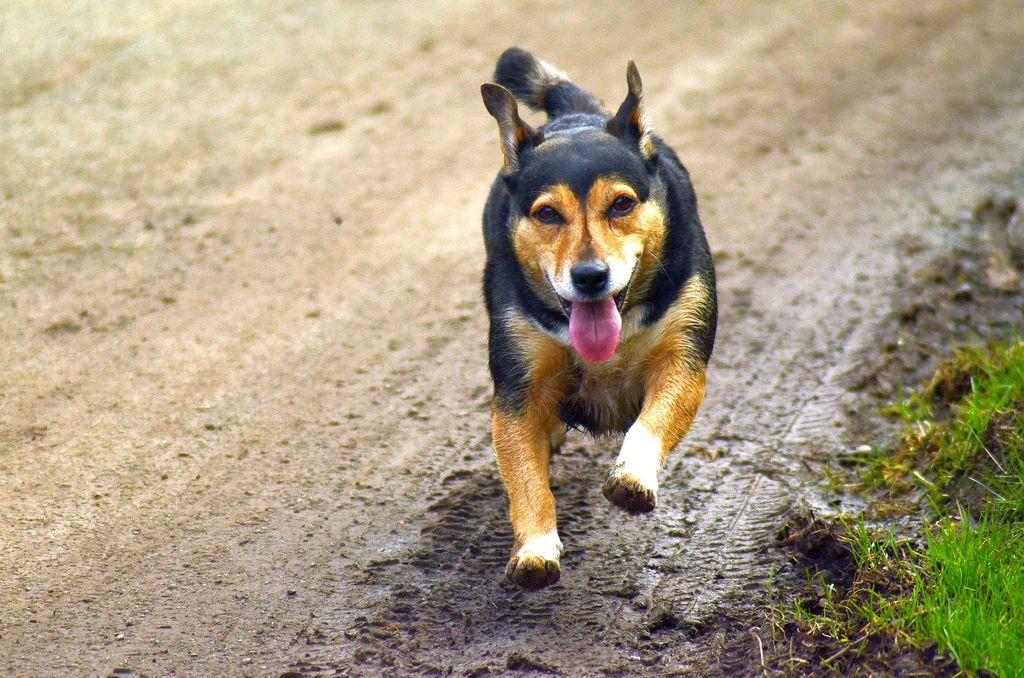What animal can be seen in the image? There is a dog in the image. What is the dog doing in the image? The dog is running on the ground. What type of surface is the dog running on? The dog is running on the ground. What can be seen on the ground in the right side at the bottom corner of the image? There is grass on the ground in the right side at the bottom corner of the image. What type of boat is visible in the image? There is no boat present in the image; it features a dog running on the ground. What kind of test is being conducted on the dog in the image? There is no test being conducted on the dog in the image; it is simply running on the ground. 